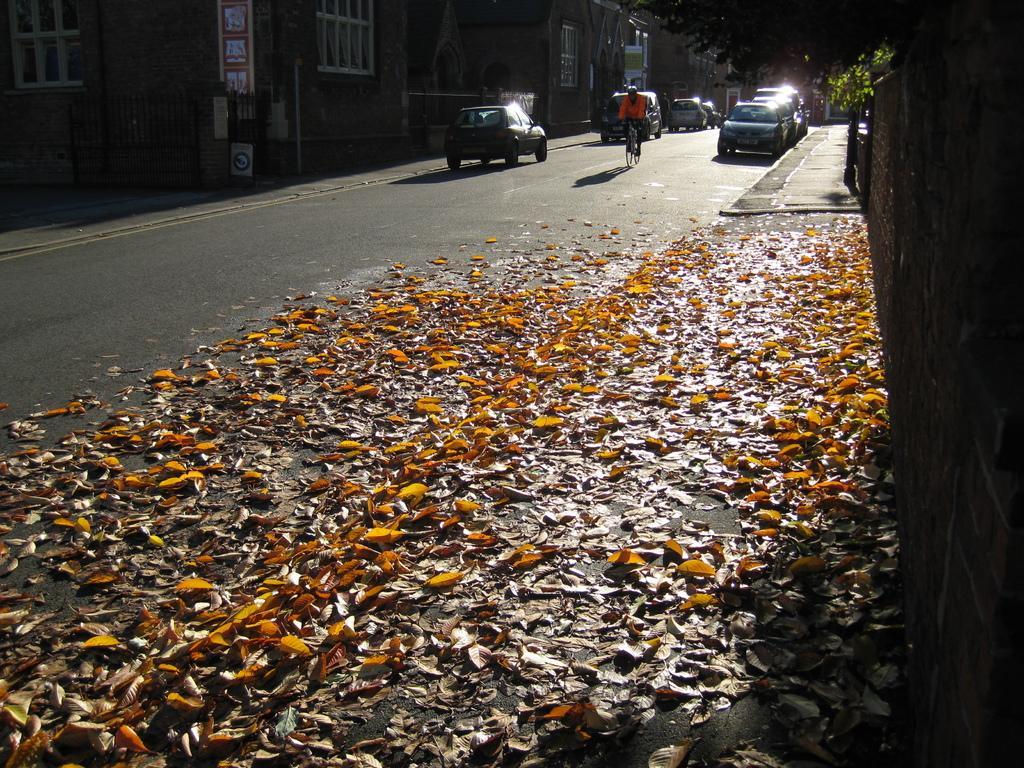Could you give a brief overview of what you see in this image? On the right side of the picture we can see the wall, trees. On the left side of the picture we can see the buildings, windows, board, fence. On the road we can see the vehicles and a person is riding a bicycle. We can see the dried leaves. 